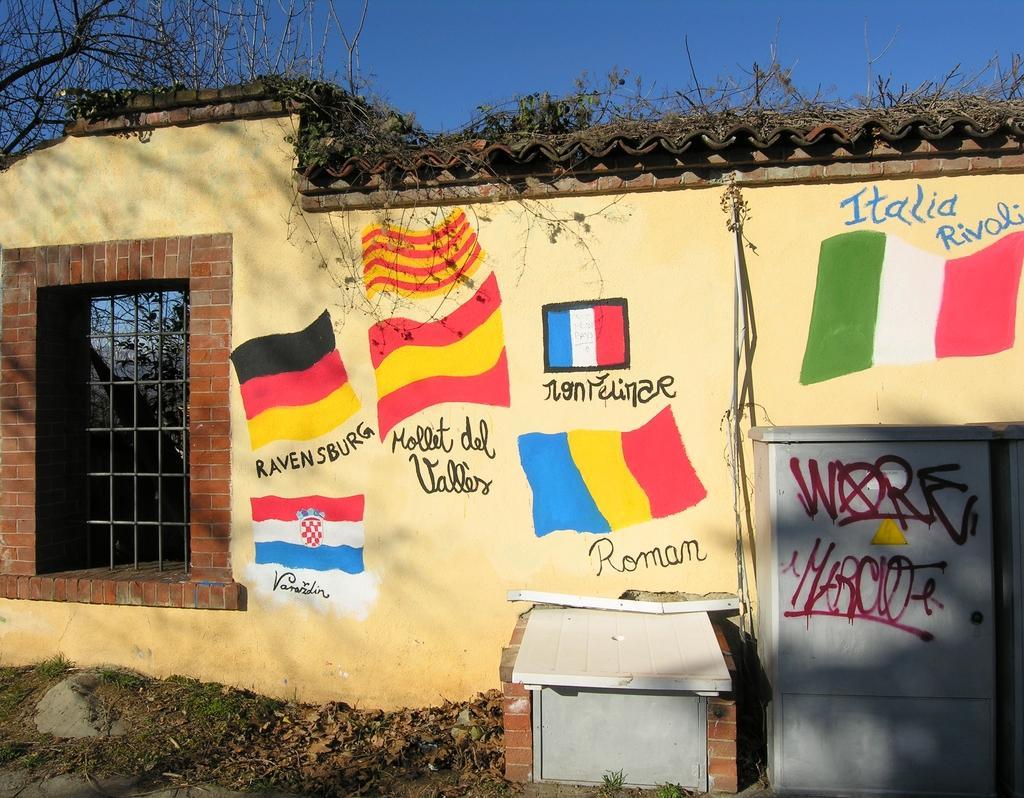How would you summarize this image in a sentence or two? There are different flags on this wall, in the left side it is an iron grill. 